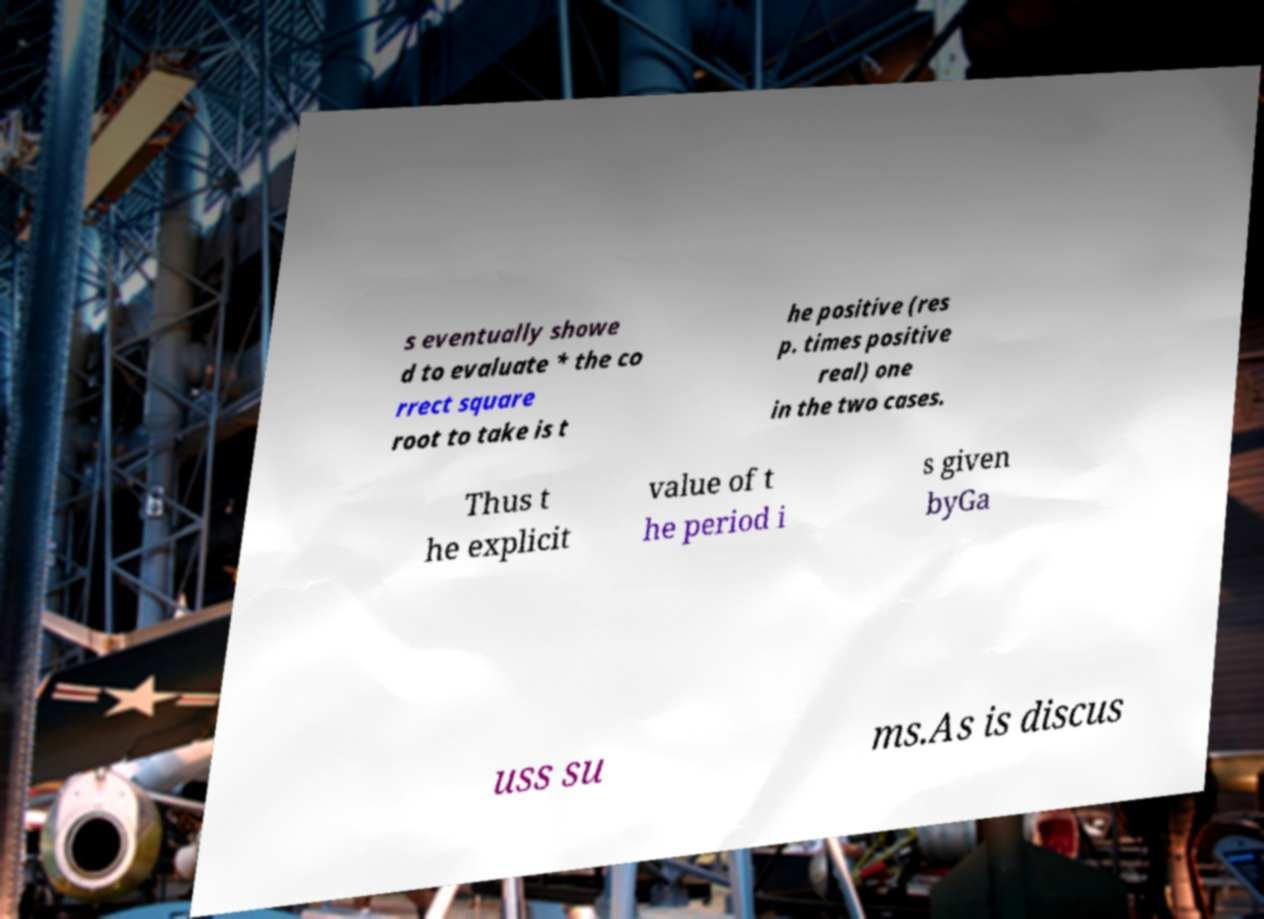For documentation purposes, I need the text within this image transcribed. Could you provide that? s eventually showe d to evaluate * the co rrect square root to take is t he positive (res p. times positive real) one in the two cases. Thus t he explicit value of t he period i s given byGa uss su ms.As is discus 